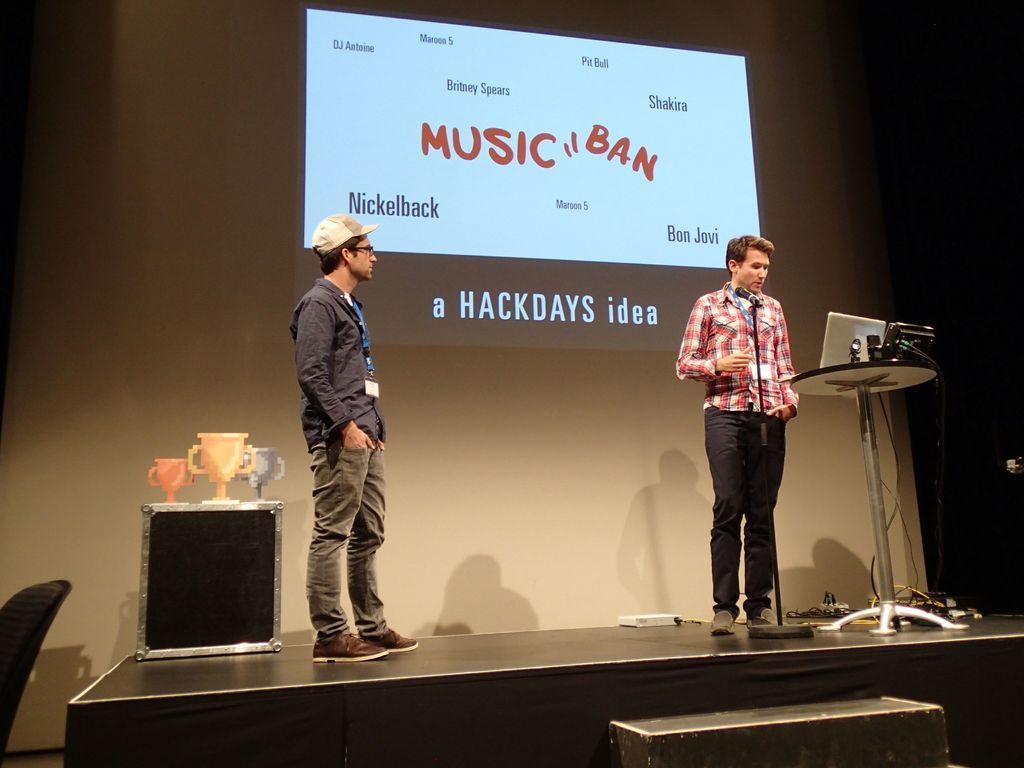In one or two sentences, can you explain what this image depicts? In this picture we can see two men standing here, there is a microphone here, on the right side there is a table, we can see a laptop on the table, on the left side we can see three trophies, in the background there is a screen. 